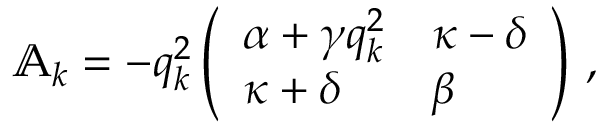Convert formula to latex. <formula><loc_0><loc_0><loc_500><loc_500>\begin{array} { r } { \mathbb { A } _ { k } = - q _ { k } ^ { 2 } \left ( \begin{array} { l l } { \alpha + \gamma q _ { k } ^ { 2 } } & { \kappa - \delta } \\ { \kappa + \delta } & { \beta } \end{array} \right ) \, , } \end{array}</formula> 